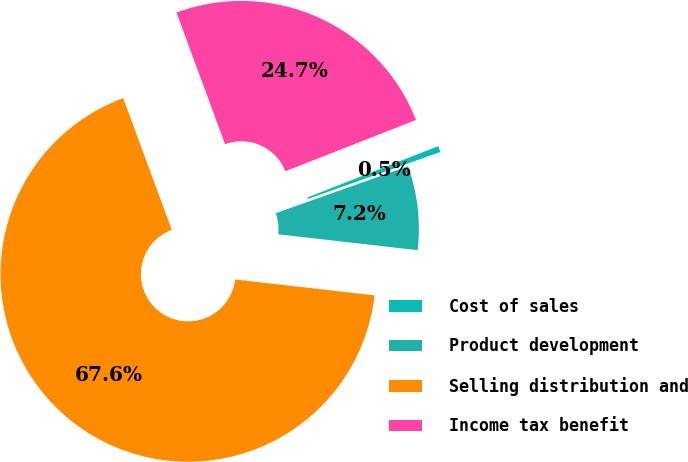Convert chart to OTSL. <chart><loc_0><loc_0><loc_500><loc_500><pie_chart><fcel>Cost of sales<fcel>Product development<fcel>Selling distribution and<fcel>Income tax benefit<nl><fcel>0.53%<fcel>7.23%<fcel>67.57%<fcel>24.67%<nl></chart> 